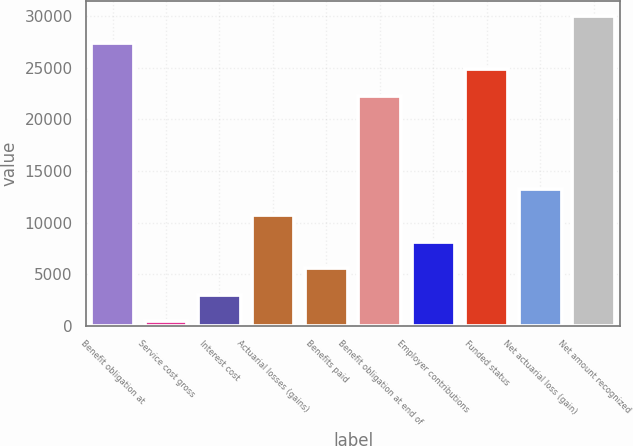Convert chart to OTSL. <chart><loc_0><loc_0><loc_500><loc_500><bar_chart><fcel>Benefit obligation at<fcel>Service cost gross<fcel>Interest cost<fcel>Actuarial losses (gains)<fcel>Benefits paid<fcel>Benefit obligation at end of<fcel>Employer contributions<fcel>Funded status<fcel>Net actuarial loss (gain)<fcel>Net amount recognized<nl><fcel>27431.4<fcel>405<fcel>2979.7<fcel>10703.8<fcel>5554.4<fcel>22282<fcel>8129.1<fcel>24856.7<fcel>13278.5<fcel>30006.1<nl></chart> 